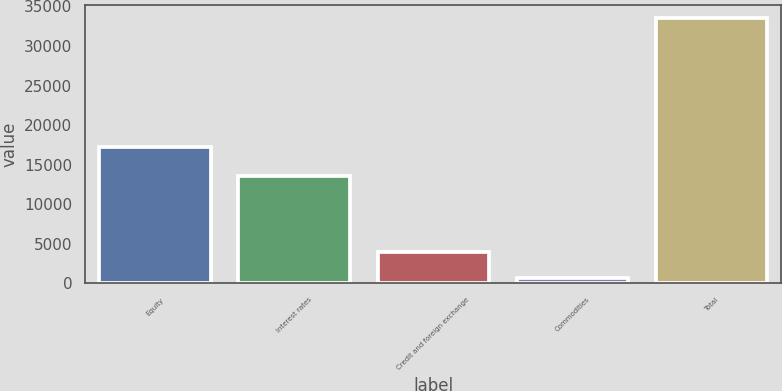Convert chart to OTSL. <chart><loc_0><loc_0><loc_500><loc_500><bar_chart><fcel>Equity<fcel>Interest rates<fcel>Credit and foreign exchange<fcel>Commodities<fcel>Total<nl><fcel>17253<fcel>13545<fcel>3926.3<fcel>636<fcel>33539<nl></chart> 